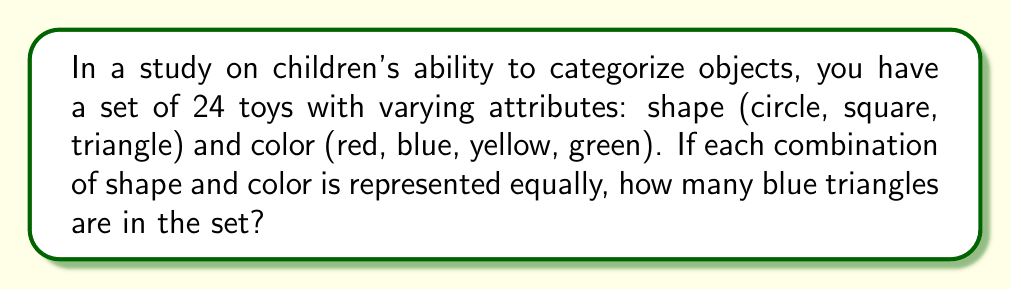Solve this math problem. Let's approach this step-by-step:

1) First, we need to determine the total number of possible combinations:
   - There are 3 shapes: circle, square, triangle
   - There are 4 colors: red, blue, yellow, green
   - Total combinations = $3 \times 4 = 12$

2) Now, we know that there are 24 toys in total, and each combination is represented equally. To find out how many of each combination there are:
   
   $\text{Number of each combination} = \frac{\text{Total toys}}{\text{Number of combinations}} = \frac{24}{12} = 2$

3) Therefore, there are 2 toys for each shape-color combination.

4) Blue triangles represent one of these combinations, so there are 2 blue triangles in the set.
Answer: 2 